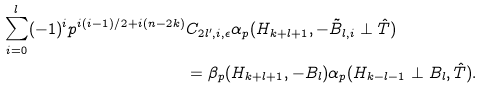Convert formula to latex. <formula><loc_0><loc_0><loc_500><loc_500>\sum _ { i = 0 } ^ { l } ( - 1 ) ^ { i } p ^ { i ( i - 1 ) / 2 + i ( n - 2 k ) } & C _ { 2 l ^ { \prime } , i , \epsilon } \alpha _ { p } ( H _ { k + l + 1 } , - \tilde { B } _ { l , i } \perp \hat { T } ) \\ & = \beta _ { p } ( H _ { k + l + 1 } , - B _ { l } ) \alpha _ { p } ( H _ { k - l - 1 } \perp B _ { l } , \hat { T } ) .</formula> 